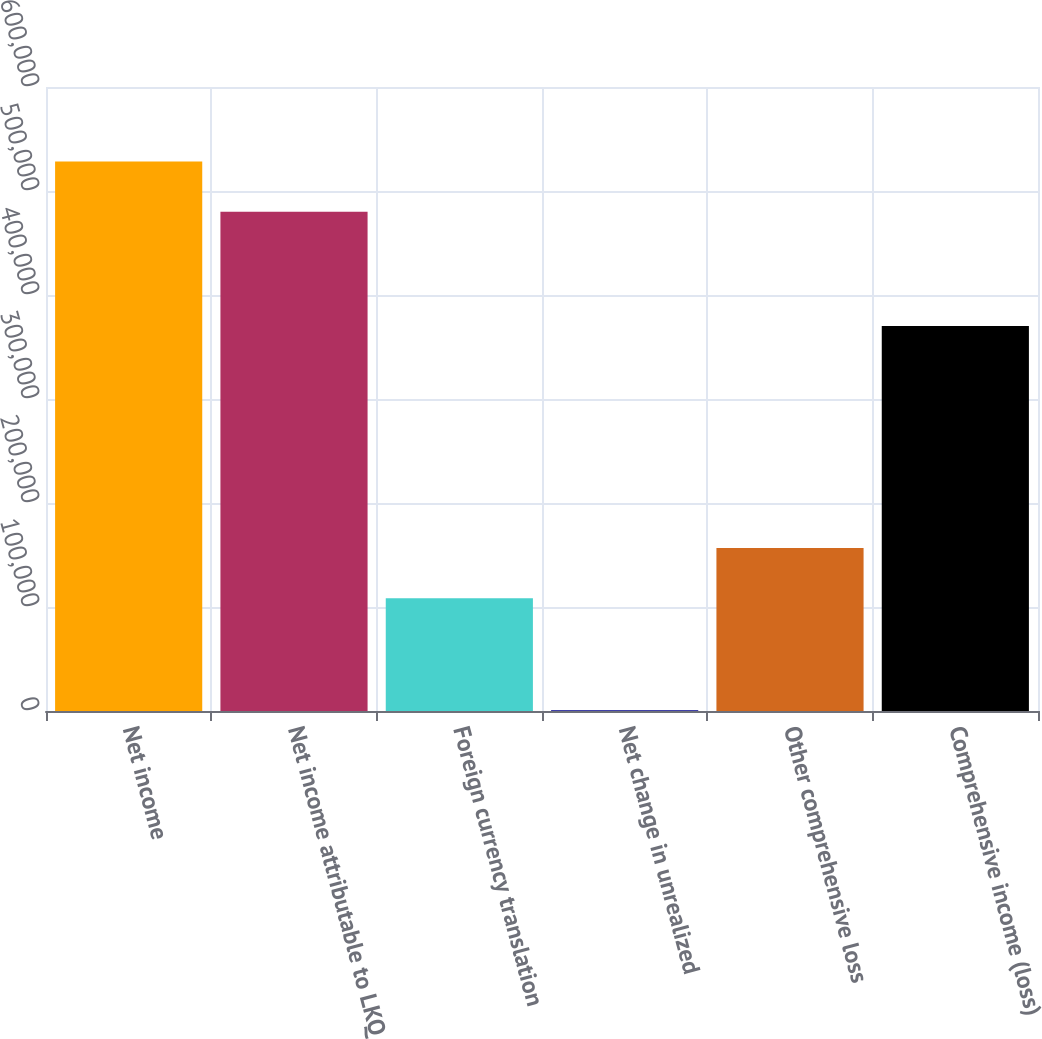Convert chart to OTSL. <chart><loc_0><loc_0><loc_500><loc_500><bar_chart><fcel>Net income<fcel>Net income attributable to LKQ<fcel>Foreign currency translation<fcel>Net change in unrealized<fcel>Other comprehensive loss<fcel>Comprehensive income (loss)<nl><fcel>528365<fcel>480118<fcel>108523<fcel>697<fcel>156770<fcel>370299<nl></chart> 